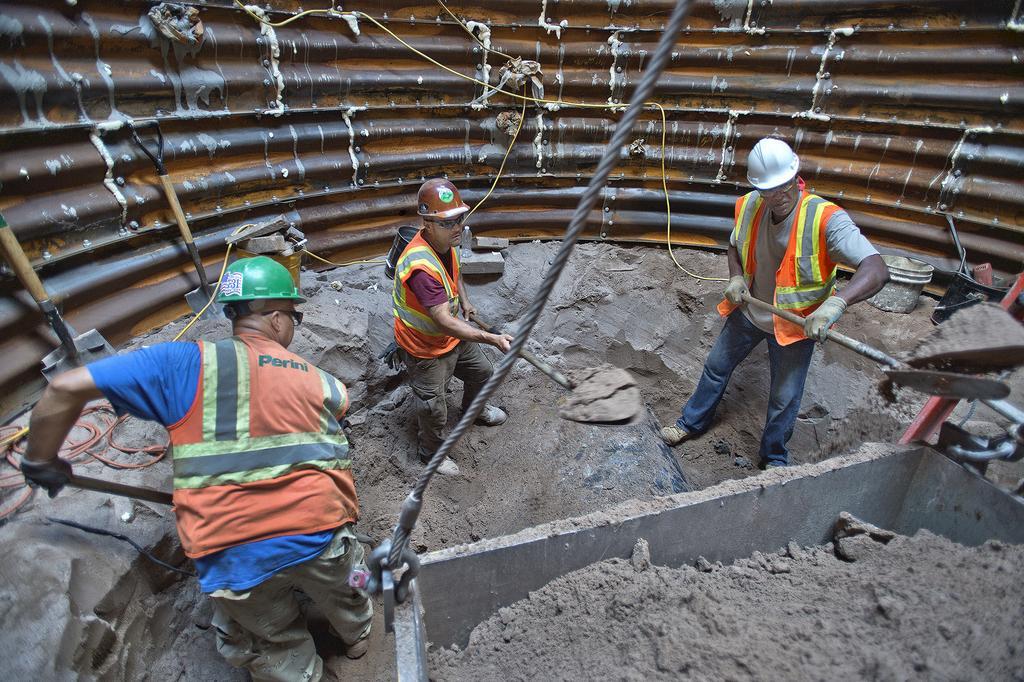Describe this image in one or two sentences. This is metal wall. These people were life jackets, helmets and holding objects. This container is attached to this rope. In this container there is a sand. Backside of these people we can see buckets, bottle and things. 